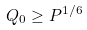<formula> <loc_0><loc_0><loc_500><loc_500>Q _ { 0 } \geq P ^ { 1 / 6 }</formula> 